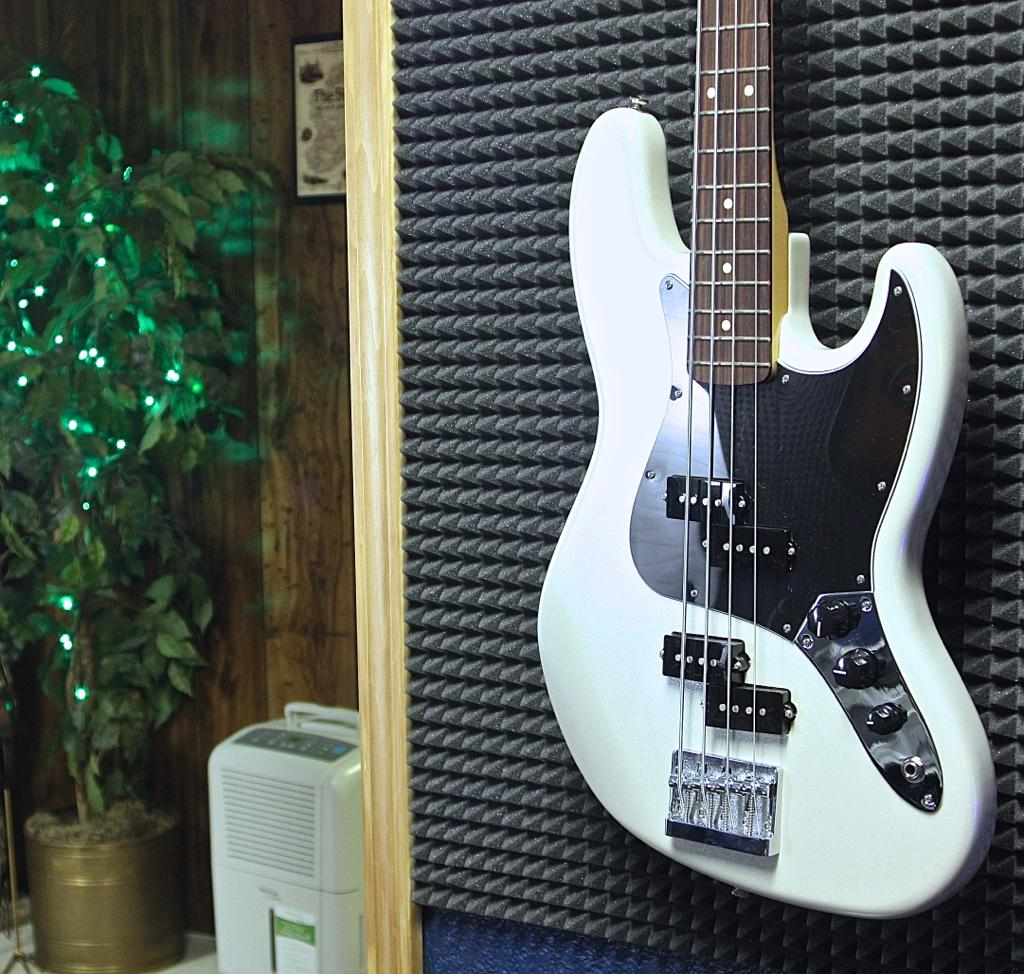What musical instrument is visible in the image? There is a guitar in the image. What can be seen in the background of the image? There is a wall, a plant, and a pot in the background of the image. Are there any fairies visible around the plant in the image? There are no fairies present in the image. What type of mist can be seen surrounding the guitar in the image? There is no mist visible in the image; the guitar and other objects are clearly visible. 